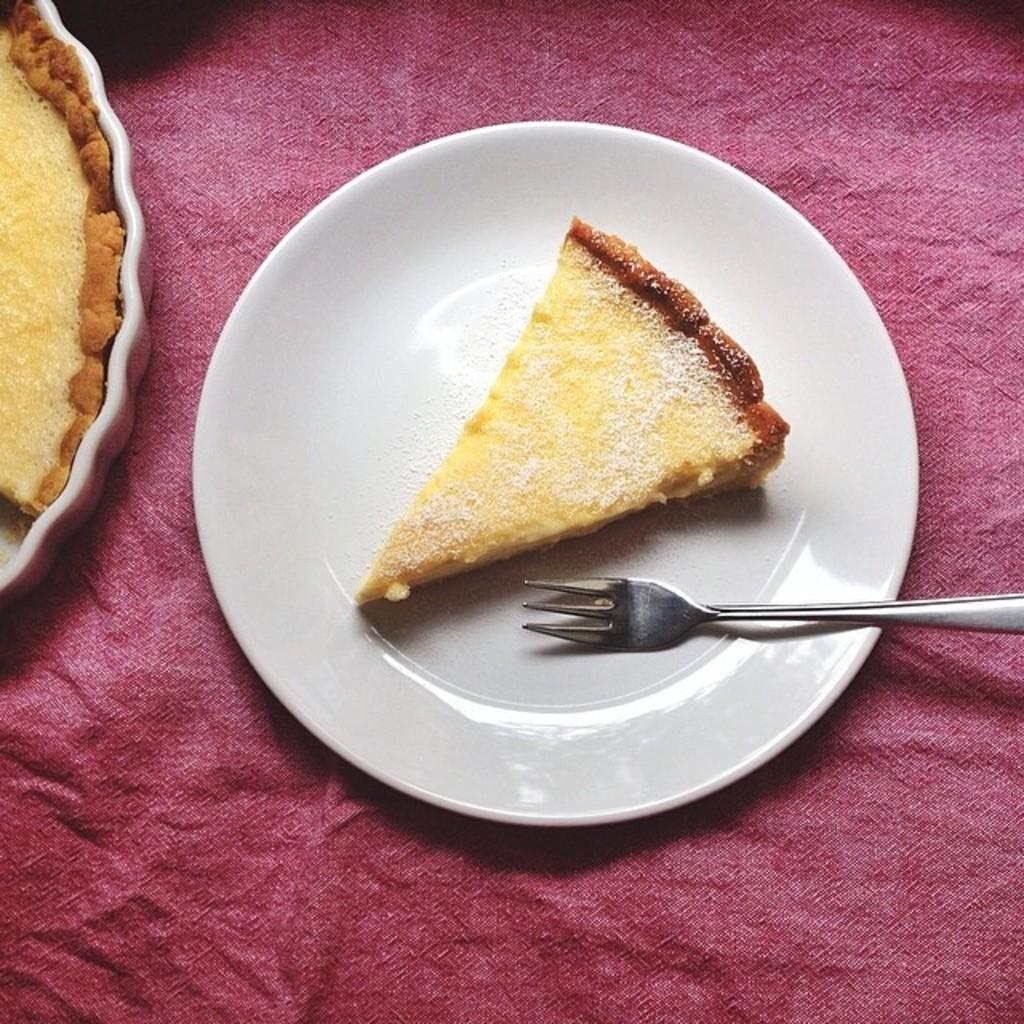What is the main food item visible in the image? There is a food item in the image, but the specific type is not mentioned in the facts. What utensil is placed on the plate in the image? There is a fork on a plate in the image. What color is the surface on which the plate is placed? The plate is placed on a red colored surface. What can be seen on the left side of the image? There is a container with food on the left side of the image. How many ladybugs are crawling on the food item in the image? There is no mention of ladybugs in the image, so we cannot determine their presence or quantity. Is the crook holding the container with food in the image? There is no mention of a crook in the image, so we cannot determine their presence or actions. 